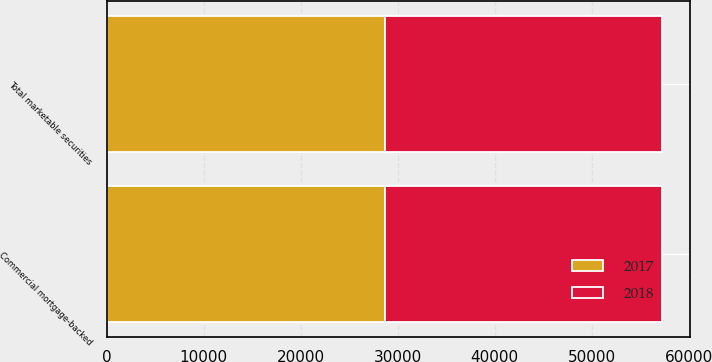Convert chart. <chart><loc_0><loc_0><loc_500><loc_500><stacked_bar_chart><ecel><fcel>Commercial mortgage-backed<fcel>Total marketable securities<nl><fcel>2017<fcel>28638<fcel>28638<nl><fcel>2018<fcel>28579<fcel>28579<nl></chart> 